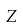<formula> <loc_0><loc_0><loc_500><loc_500>Z</formula> 